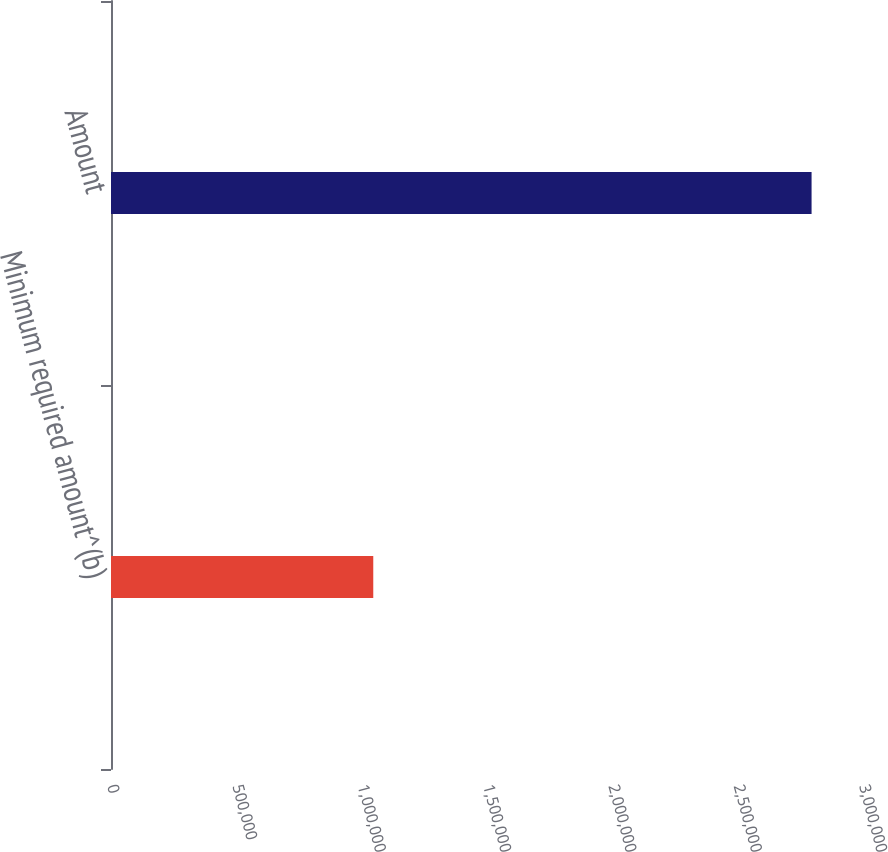<chart> <loc_0><loc_0><loc_500><loc_500><bar_chart><fcel>Minimum required amount^(b)<fcel>Amount<nl><fcel>1.04628e+06<fcel>2.79483e+06<nl></chart> 